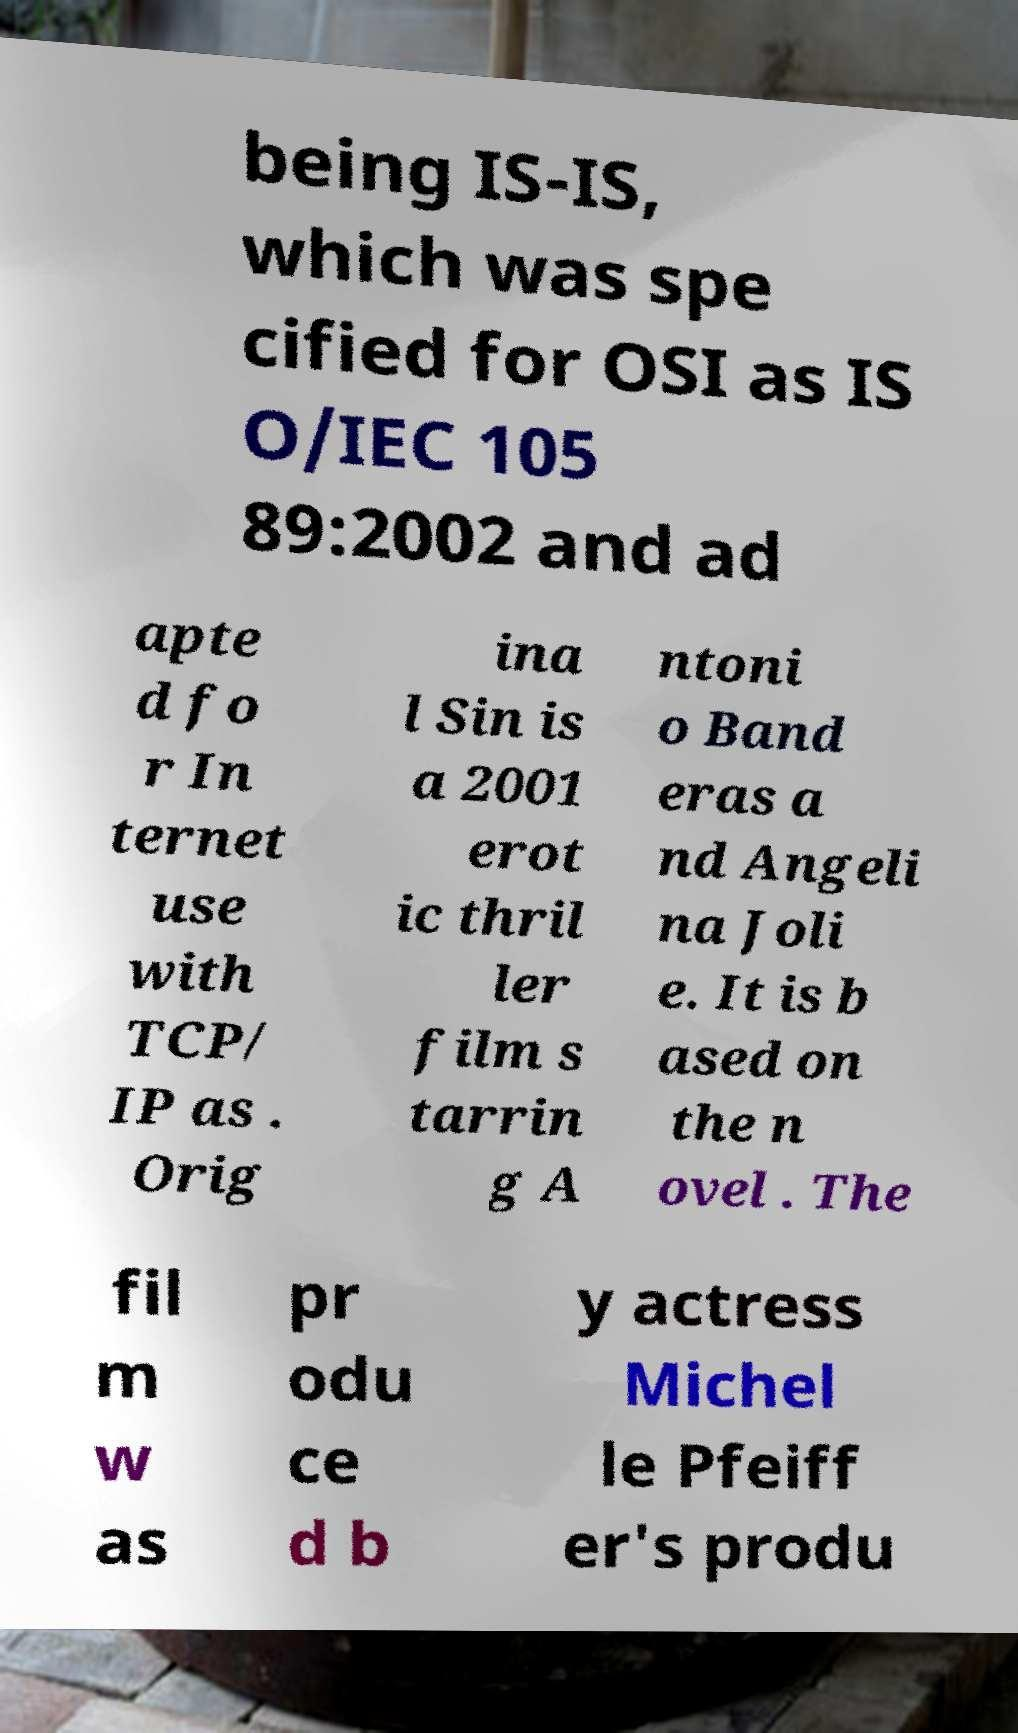I need the written content from this picture converted into text. Can you do that? being IS-IS, which was spe cified for OSI as IS O/IEC 105 89:2002 and ad apte d fo r In ternet use with TCP/ IP as . Orig ina l Sin is a 2001 erot ic thril ler film s tarrin g A ntoni o Band eras a nd Angeli na Joli e. It is b ased on the n ovel . The fil m w as pr odu ce d b y actress Michel le Pfeiff er's produ 